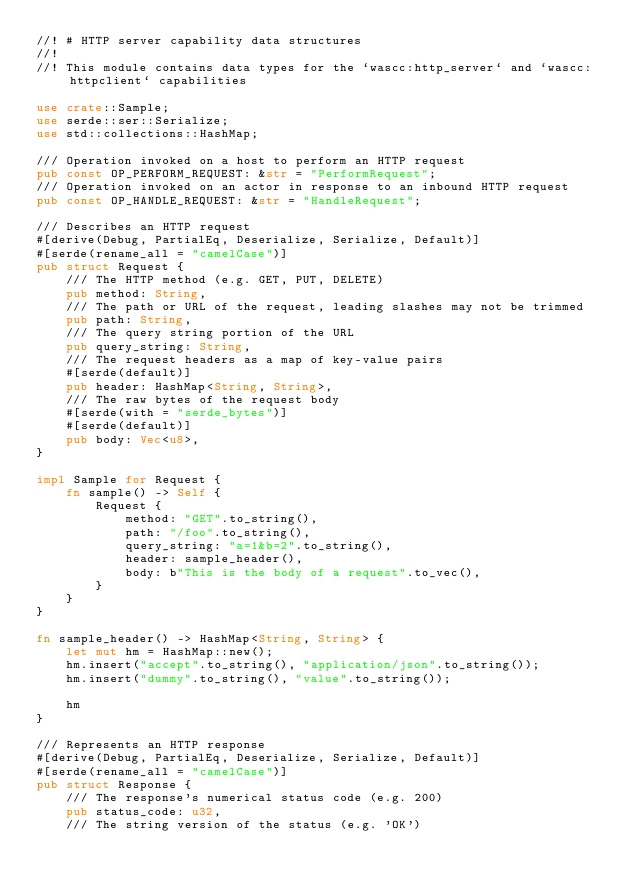<code> <loc_0><loc_0><loc_500><loc_500><_Rust_>//! # HTTP server capability data structures
//!
//! This module contains data types for the `wascc:http_server` and `wascc:httpclient` capabilities

use crate::Sample;
use serde::ser::Serialize;
use std::collections::HashMap;

/// Operation invoked on a host to perform an HTTP request
pub const OP_PERFORM_REQUEST: &str = "PerformRequest";
/// Operation invoked on an actor in response to an inbound HTTP request
pub const OP_HANDLE_REQUEST: &str = "HandleRequest";

/// Describes an HTTP request
#[derive(Debug, PartialEq, Deserialize, Serialize, Default)]
#[serde(rename_all = "camelCase")]
pub struct Request {
    /// The HTTP method (e.g. GET, PUT, DELETE)
    pub method: String,
    /// The path or URL of the request, leading slashes may not be trimmed
    pub path: String,
    /// The query string portion of the URL
    pub query_string: String,
    /// The request headers as a map of key-value pairs
    #[serde(default)]
    pub header: HashMap<String, String>,
    /// The raw bytes of the request body
    #[serde(with = "serde_bytes")]
    #[serde(default)]
    pub body: Vec<u8>,
}

impl Sample for Request {
    fn sample() -> Self {
        Request {
            method: "GET".to_string(),
            path: "/foo".to_string(),
            query_string: "a=1&b=2".to_string(),
            header: sample_header(),
            body: b"This is the body of a request".to_vec(),
        }
    }
}

fn sample_header() -> HashMap<String, String> {
    let mut hm = HashMap::new();
    hm.insert("accept".to_string(), "application/json".to_string());
    hm.insert("dummy".to_string(), "value".to_string());

    hm
}

/// Represents an HTTP response
#[derive(Debug, PartialEq, Deserialize, Serialize, Default)]
#[serde(rename_all = "camelCase")]
pub struct Response {
    /// The response's numerical status code (e.g. 200)
    pub status_code: u32,
    /// The string version of the status (e.g. 'OK')</code> 